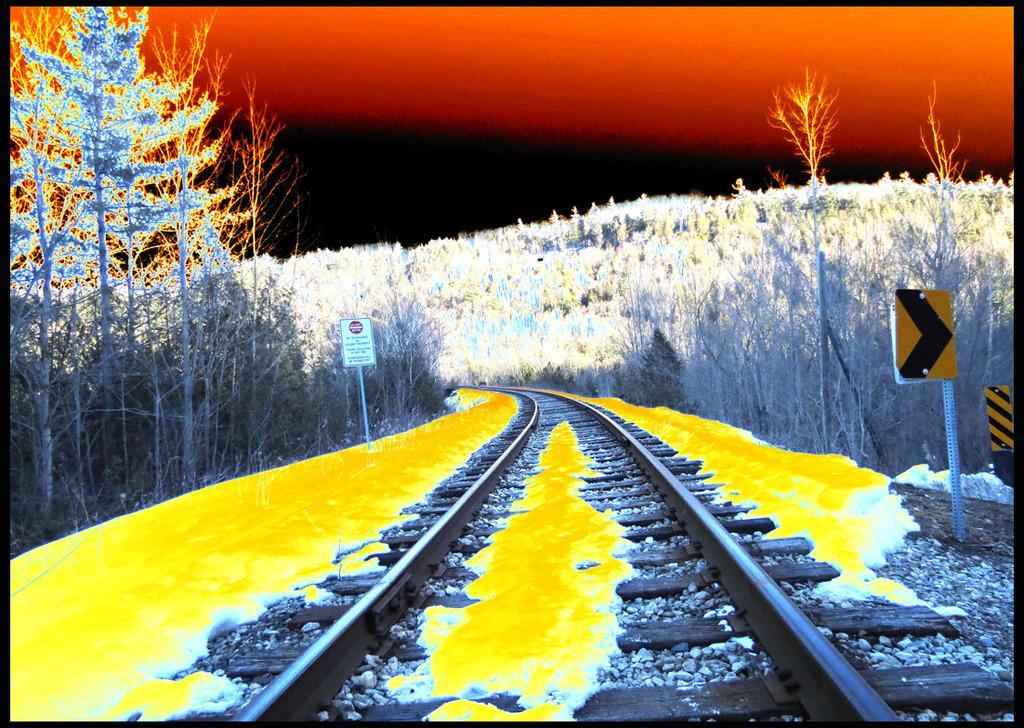Could you give a brief overview of what you see in this image? This looks like an edited image. This is a railway track. These are the sign boards attached to the poles. I can see the trees. 